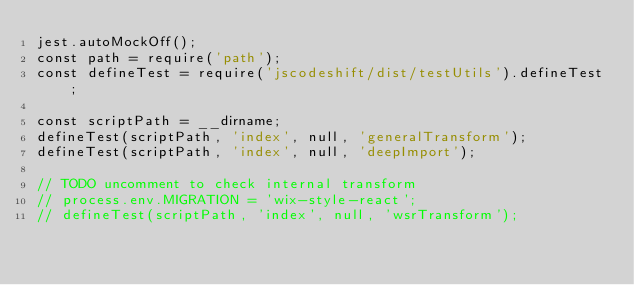<code> <loc_0><loc_0><loc_500><loc_500><_JavaScript_>jest.autoMockOff();
const path = require('path');
const defineTest = require('jscodeshift/dist/testUtils').defineTest;

const scriptPath = __dirname;
defineTest(scriptPath, 'index', null, 'generalTransform');
defineTest(scriptPath, 'index', null, 'deepImport');

// TODO uncomment to check internal transform
// process.env.MIGRATION = 'wix-style-react';
// defineTest(scriptPath, 'index', null, 'wsrTransform');

</code> 